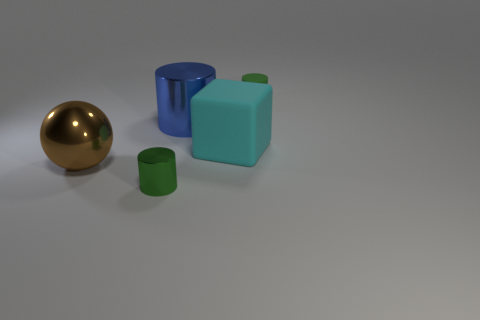Add 4 shiny cylinders. How many objects exist? 9 Subtract all blocks. How many objects are left? 4 Add 5 big blue shiny objects. How many big blue shiny objects are left? 6 Add 2 tiny green metal cylinders. How many tiny green metal cylinders exist? 3 Subtract 2 green cylinders. How many objects are left? 3 Subtract all small yellow matte objects. Subtract all green rubber cylinders. How many objects are left? 4 